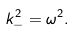Convert formula to latex. <formula><loc_0><loc_0><loc_500><loc_500>k _ { - } ^ { 2 } = \omega ^ { 2 } .</formula> 